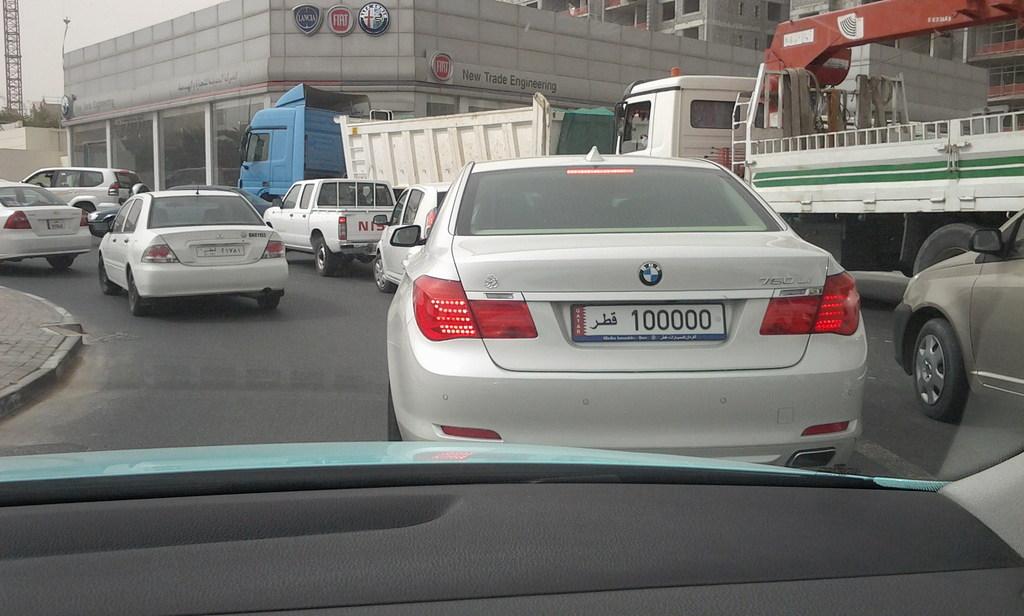What is the license plate number of the car closest to your view?
Give a very brief answer. 100000. What car company is in the red symbol on the building?
Offer a terse response. Fiat. 